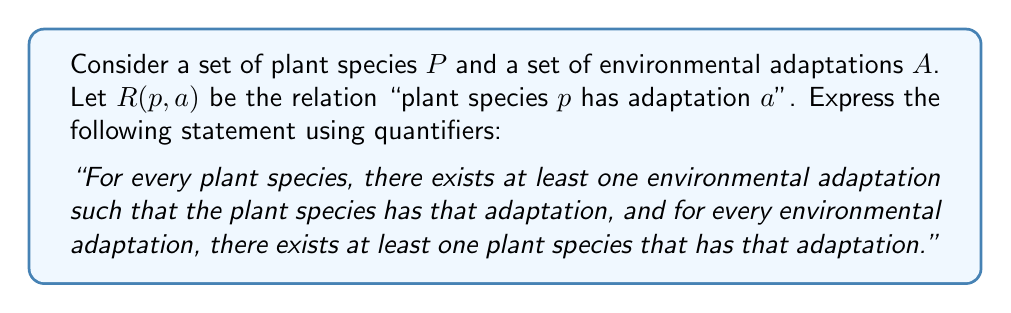Can you answer this question? To express this statement using quantifiers, we need to break it down into two parts and then combine them:

1. "For every plant species, there exists at least one environmental adaptation such that the plant species has that adaptation":
   This can be expressed as: $\forall p \in P, \exists a \in A : R(p,a)$

2. "For every environmental adaptation, there exists at least one plant species that has that adaptation":
   This can be expressed as: $\forall a \in A, \exists p \in P : R(p,a)$

To combine these two statements, we use the logical conjunction (AND) operator, denoted by $\land$.

Therefore, the complete statement using quantifiers is:

$$(\forall p \in P, \exists a \in A : R(p,a)) \land (\forall a \in A, \exists p \in P : R(p,a))$$

This logical expression captures the relationship between plant species and their environmental adaptations as described in the original statement.
Answer: $$(\forall p \in P, \exists a \in A : R(p,a)) \land (\forall a \in A, \exists p \in P : R(p,a))$$ 